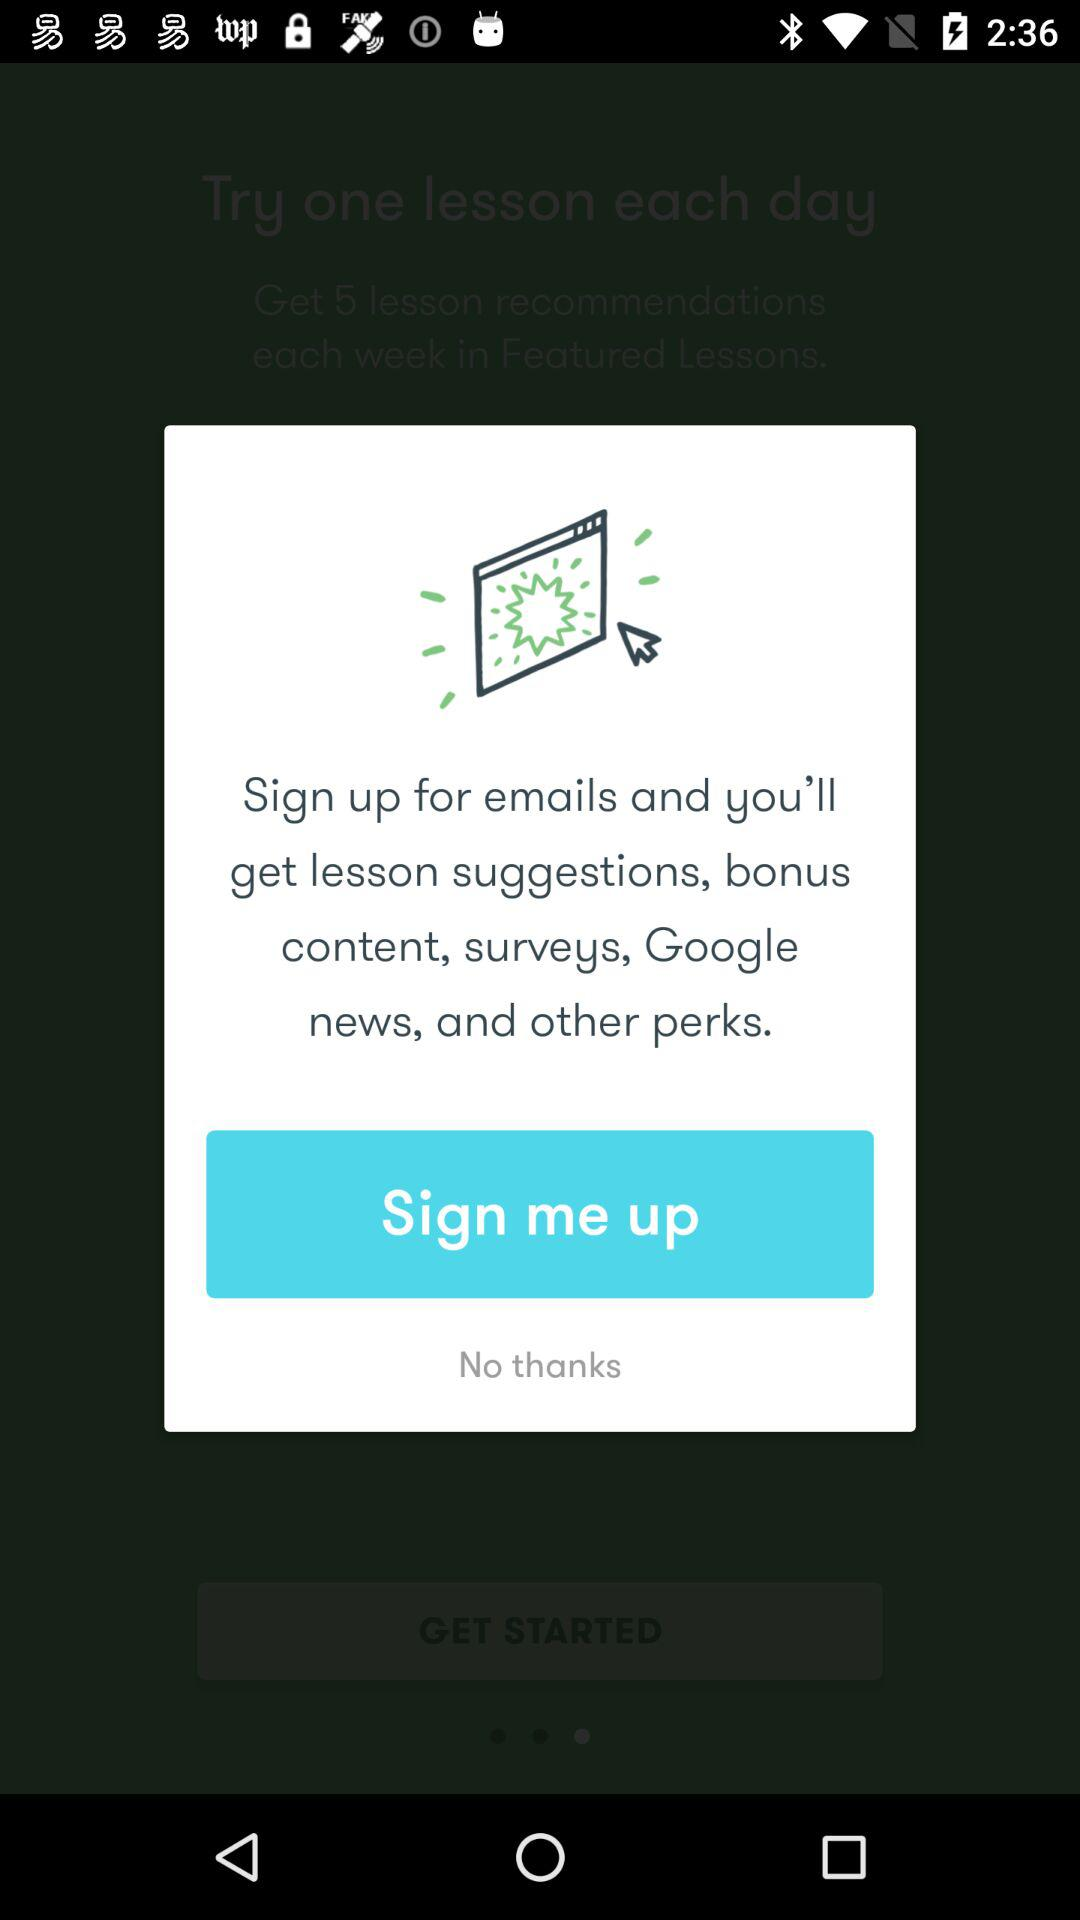What will I get after signing up for emails? You will get lesson suggestions, bonus content, surveys, Google news and other perks after signing up for emails. 